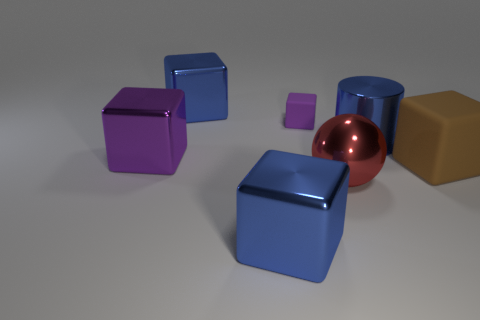Subtract all rubber blocks. How many blocks are left? 3 Subtract all blue cubes. How many cubes are left? 3 Add 3 metal blocks. How many objects exist? 10 Subtract all green cubes. Subtract all yellow cylinders. How many cubes are left? 5 Subtract all cylinders. How many objects are left? 6 Subtract all red balls. Subtract all large purple things. How many objects are left? 5 Add 7 cylinders. How many cylinders are left? 8 Add 6 big gray matte objects. How many big gray matte objects exist? 6 Subtract 0 blue balls. How many objects are left? 7 